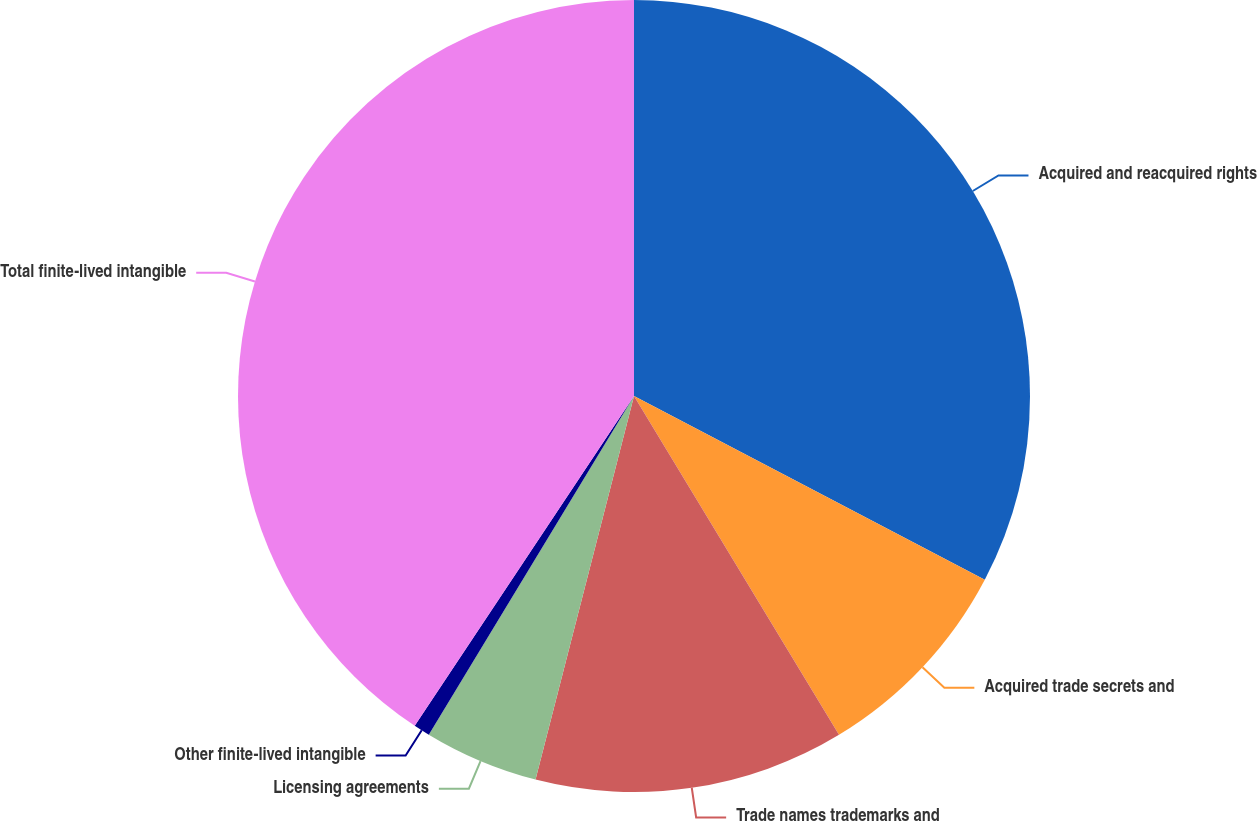Convert chart to OTSL. <chart><loc_0><loc_0><loc_500><loc_500><pie_chart><fcel>Acquired and reacquired rights<fcel>Acquired trade secrets and<fcel>Trade names trademarks and<fcel>Licensing agreements<fcel>Other finite-lived intangible<fcel>Total finite-lived intangible<nl><fcel>32.68%<fcel>8.66%<fcel>12.66%<fcel>4.67%<fcel>0.67%<fcel>40.66%<nl></chart> 